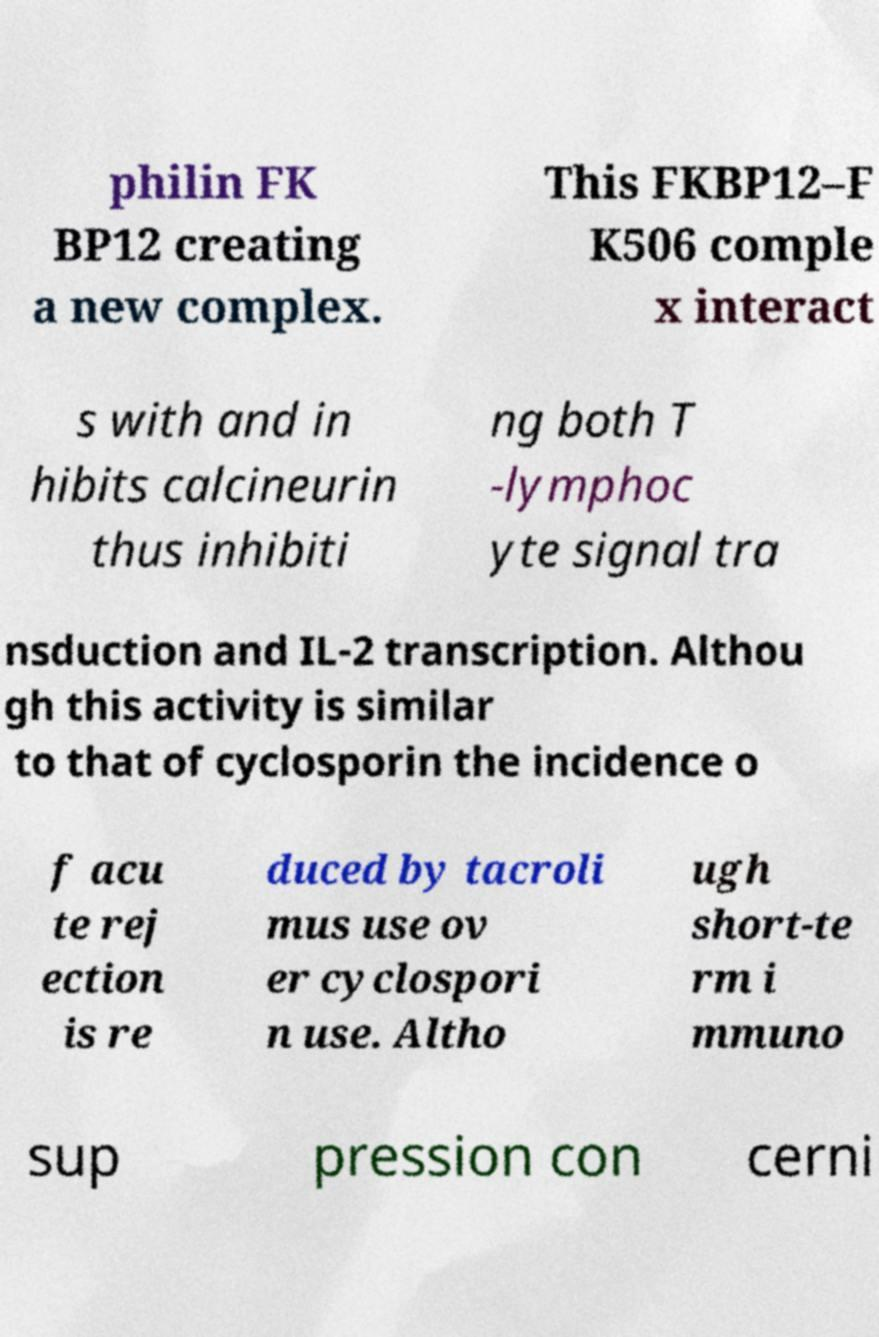Can you accurately transcribe the text from the provided image for me? philin FK BP12 creating a new complex. This FKBP12–F K506 comple x interact s with and in hibits calcineurin thus inhibiti ng both T -lymphoc yte signal tra nsduction and IL-2 transcription. Althou gh this activity is similar to that of cyclosporin the incidence o f acu te rej ection is re duced by tacroli mus use ov er cyclospori n use. Altho ugh short-te rm i mmuno sup pression con cerni 